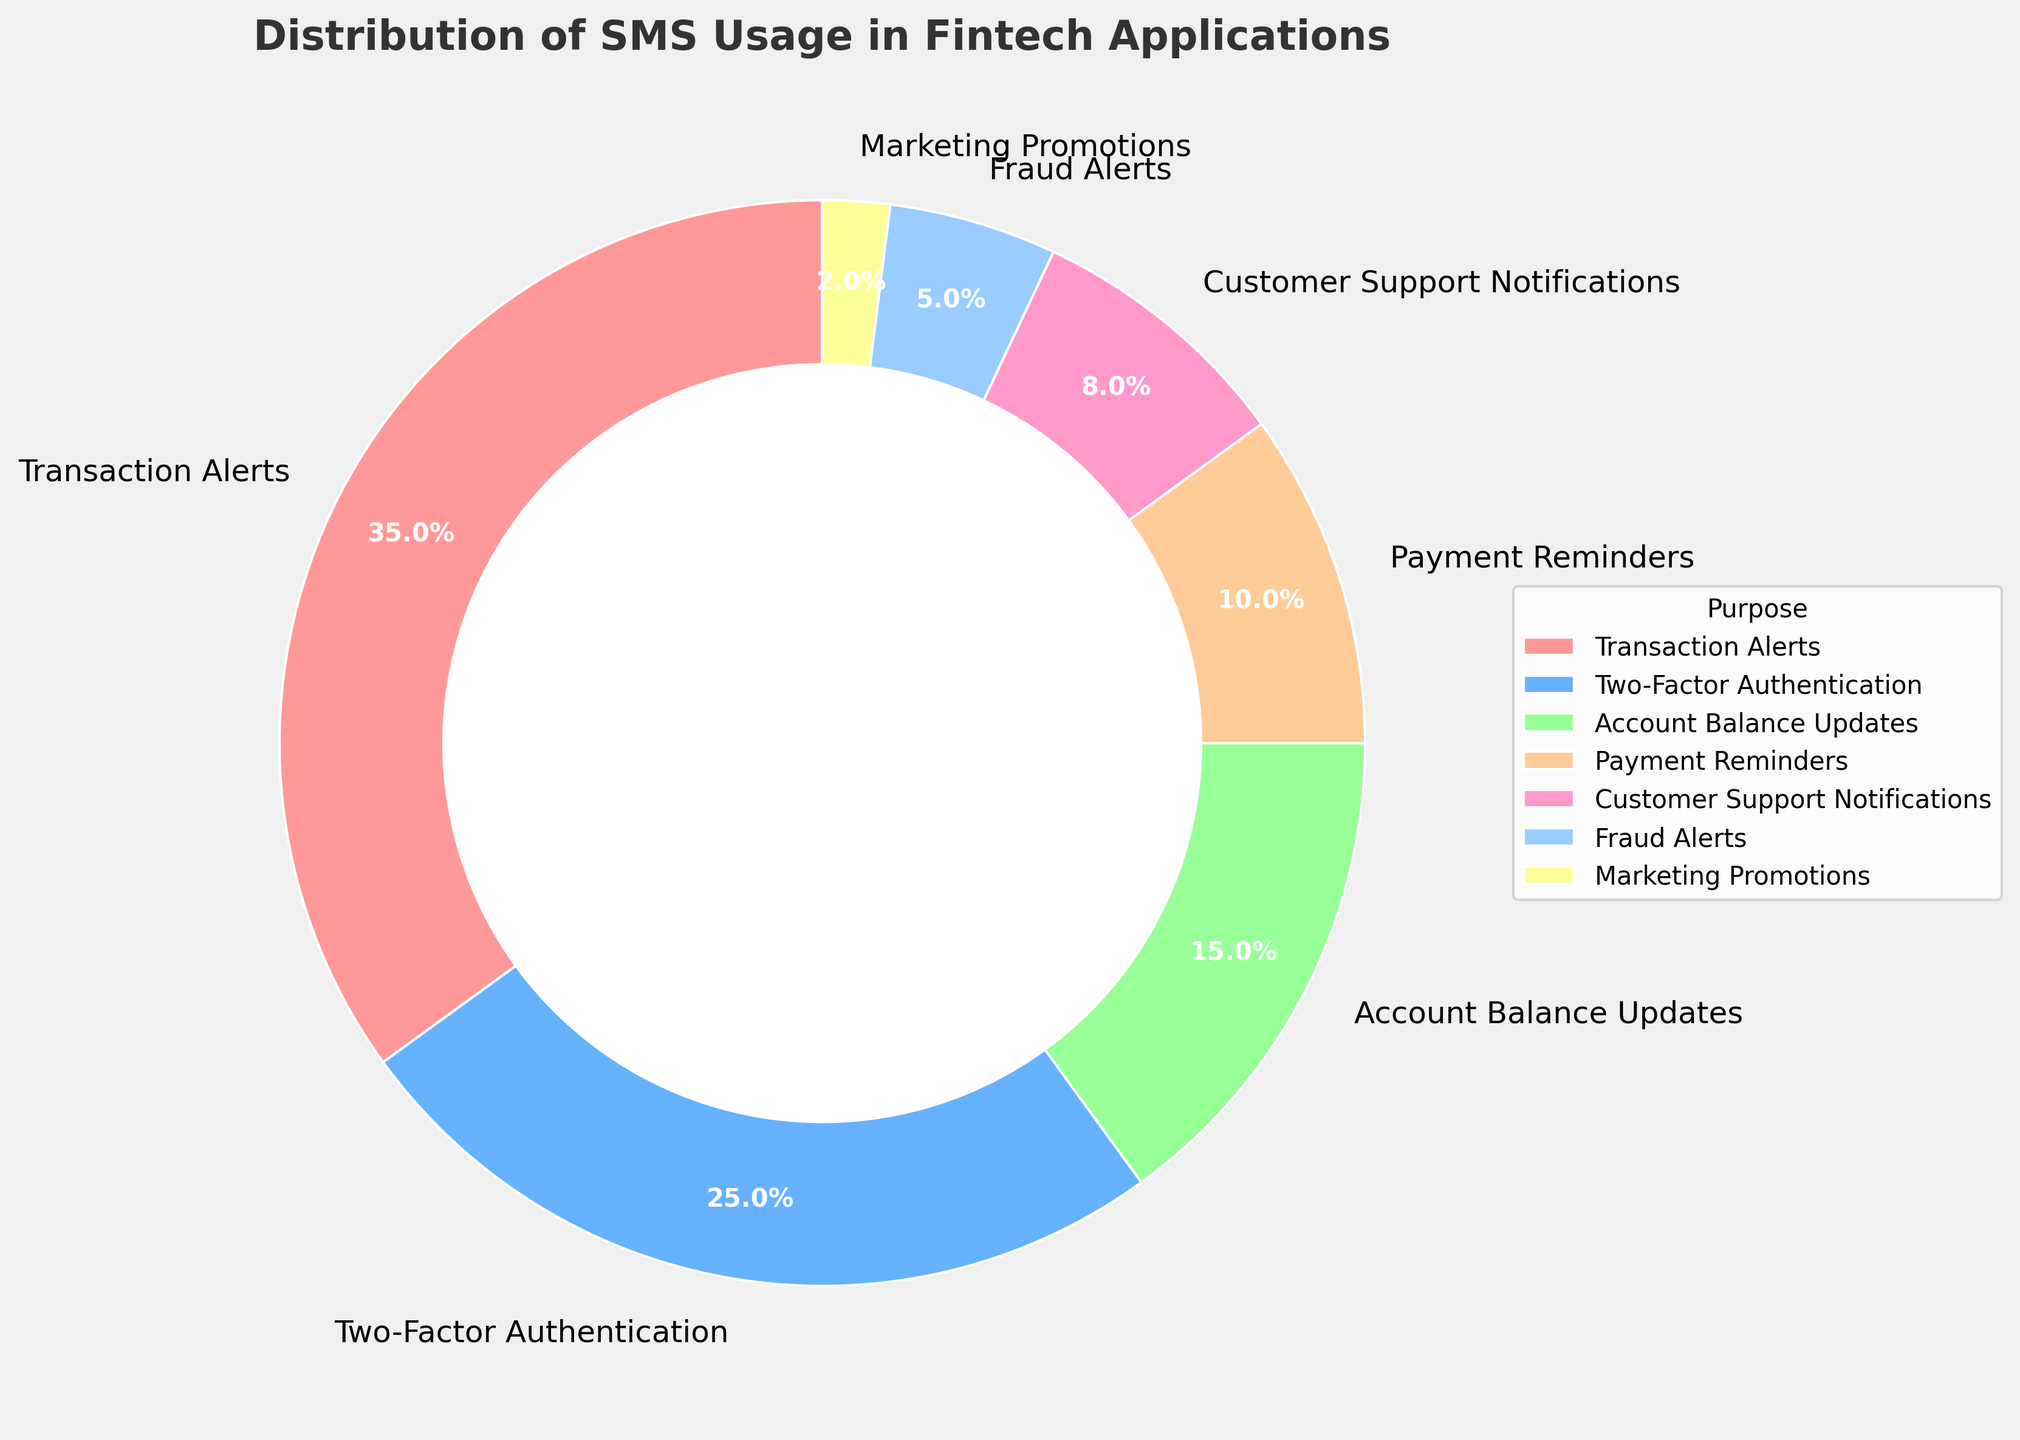Which purpose has the highest percentage in the distribution? The highest percentage is visually identified by the largest wedge in the pie chart, which corresponds to "Transaction Alerts" with 35%.
Answer: Transaction Alerts Which two purposes have the smallest percentages, and what are they? The smallest wedges in the pie chart represent the purposes with the smallest percentages, which are "Marketing Promotions" with 2% and "Fraud Alerts" with 5%.
Answer: Marketing Promotions and Fraud Alerts What is the combined percentage of Two-Factor Authentication and Payment Reminders? To find the combined percentage, sum the percentages of Two-Factor Authentication (25%) and Payment Reminders (10%): 25% + 10% = 35%.
Answer: 35% Which purpose has a higher percentage: Account Balance Updates or Customer Support Notifications? Compare the wedges of "Account Balance Updates" (15%) and "Customer Support Notifications" (8%). 15% is higher than 8%.
Answer: Account Balance Updates How much larger is the percentage of Transaction Alerts compared to Fraud Alerts? Subtract the percentage of Fraud Alerts (5%) from Transaction Alerts (35%): 35% - 5% = 30%.
Answer: 30% What is the difference in percentage between Payment Reminders and Marketing Promotions? Subtract the percentage of Marketing Promotions (2%) from Payment Reminders (10%): 10% - 2% = 8%.
Answer: 8% What is the average percentage of the top three categories? The top three categories are Transaction Alerts (35%), Two-Factor Authentication (25%), and Account Balance Updates (15%). Sum these percentages and then divide by 3: (35% + 25% + 15%) / 3 = 75% / 3 = 25%.
Answer: 25% What color is used to represent Customer Support Notifications? Identify the wedge corresponding to Customer Support Notifications in the chart and the associated color, which is visually noticeable as one of the distinct colors. The color is a pinkish shade.
Answer: Pinkish shade Which purposes together make up more than half (50%) of the distribution? Identify and sum the most significant portions until the total exceeds 50%. Transaction Alerts (35%) + Two-Factor Authentication (25%) = 60%, which is more than 50%.
Answer: Transaction Alerts and Two-Factor Authentication 